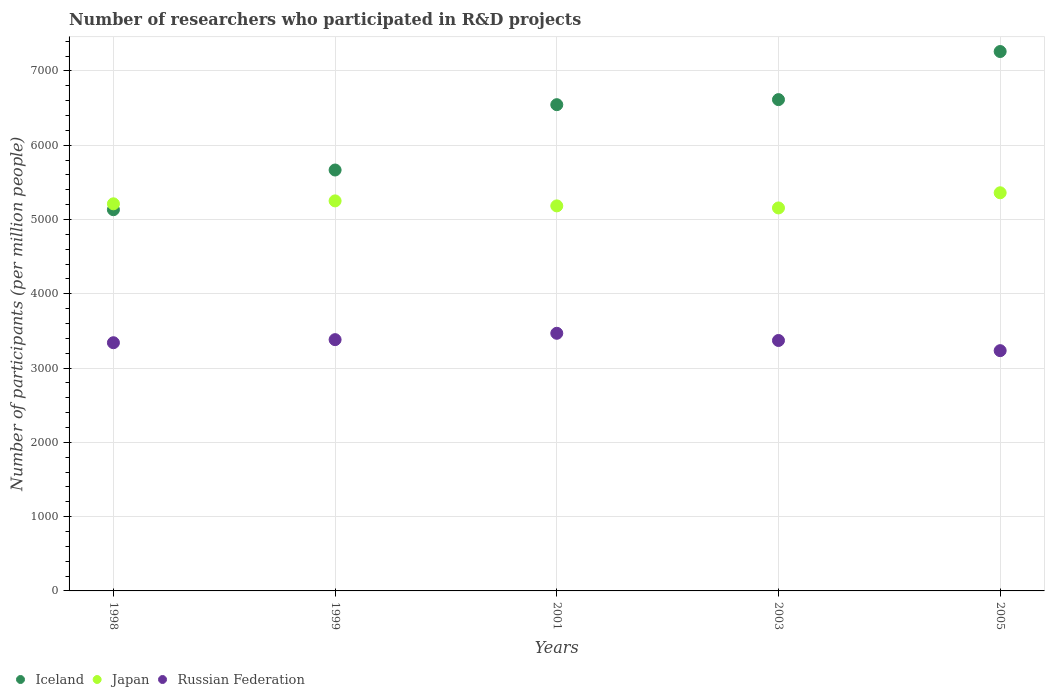Is the number of dotlines equal to the number of legend labels?
Give a very brief answer. Yes. What is the number of researchers who participated in R&D projects in Japan in 2003?
Your answer should be very brief. 5156.09. Across all years, what is the maximum number of researchers who participated in R&D projects in Japan?
Keep it short and to the point. 5360.2. Across all years, what is the minimum number of researchers who participated in R&D projects in Iceland?
Give a very brief answer. 5132.28. What is the total number of researchers who participated in R&D projects in Iceland in the graph?
Provide a succinct answer. 3.12e+04. What is the difference between the number of researchers who participated in R&D projects in Iceland in 1998 and that in 1999?
Your response must be concise. -534.51. What is the difference between the number of researchers who participated in R&D projects in Russian Federation in 1998 and the number of researchers who participated in R&D projects in Iceland in 2005?
Your response must be concise. -3920.25. What is the average number of researchers who participated in R&D projects in Russian Federation per year?
Provide a short and direct response. 3359.86. In the year 1999, what is the difference between the number of researchers who participated in R&D projects in Japan and number of researchers who participated in R&D projects in Russian Federation?
Offer a very short reply. 1868.17. In how many years, is the number of researchers who participated in R&D projects in Russian Federation greater than 7000?
Offer a very short reply. 0. What is the ratio of the number of researchers who participated in R&D projects in Russian Federation in 1999 to that in 2001?
Your answer should be very brief. 0.98. Is the number of researchers who participated in R&D projects in Iceland in 2001 less than that in 2005?
Ensure brevity in your answer.  Yes. What is the difference between the highest and the second highest number of researchers who participated in R&D projects in Japan?
Offer a very short reply. 109.12. What is the difference between the highest and the lowest number of researchers who participated in R&D projects in Iceland?
Provide a short and direct response. 2129.51. In how many years, is the number of researchers who participated in R&D projects in Japan greater than the average number of researchers who participated in R&D projects in Japan taken over all years?
Offer a terse response. 2. Is it the case that in every year, the sum of the number of researchers who participated in R&D projects in Japan and number of researchers who participated in R&D projects in Russian Federation  is greater than the number of researchers who participated in R&D projects in Iceland?
Make the answer very short. Yes. Is the number of researchers who participated in R&D projects in Japan strictly less than the number of researchers who participated in R&D projects in Iceland over the years?
Ensure brevity in your answer.  No. What is the difference between two consecutive major ticks on the Y-axis?
Your response must be concise. 1000. How are the legend labels stacked?
Offer a very short reply. Horizontal. What is the title of the graph?
Offer a terse response. Number of researchers who participated in R&D projects. Does "China" appear as one of the legend labels in the graph?
Offer a very short reply. No. What is the label or title of the X-axis?
Offer a very short reply. Years. What is the label or title of the Y-axis?
Your answer should be compact. Number of participants (per million people). What is the Number of participants (per million people) in Iceland in 1998?
Provide a short and direct response. 5132.28. What is the Number of participants (per million people) of Japan in 1998?
Make the answer very short. 5211.65. What is the Number of participants (per million people) of Russian Federation in 1998?
Offer a terse response. 3341.54. What is the Number of participants (per million people) in Iceland in 1999?
Make the answer very short. 5666.8. What is the Number of participants (per million people) of Japan in 1999?
Give a very brief answer. 5251.07. What is the Number of participants (per million people) of Russian Federation in 1999?
Provide a succinct answer. 3382.9. What is the Number of participants (per million people) of Iceland in 2001?
Offer a very short reply. 6546.33. What is the Number of participants (per million people) in Japan in 2001?
Your answer should be compact. 5183.76. What is the Number of participants (per million people) in Russian Federation in 2001?
Your answer should be compact. 3468.55. What is the Number of participants (per million people) of Iceland in 2003?
Ensure brevity in your answer.  6614.36. What is the Number of participants (per million people) in Japan in 2003?
Provide a succinct answer. 5156.09. What is the Number of participants (per million people) in Russian Federation in 2003?
Offer a very short reply. 3371.6. What is the Number of participants (per million people) in Iceland in 2005?
Give a very brief answer. 7261.79. What is the Number of participants (per million people) in Japan in 2005?
Give a very brief answer. 5360.2. What is the Number of participants (per million people) of Russian Federation in 2005?
Keep it short and to the point. 3234.71. Across all years, what is the maximum Number of participants (per million people) of Iceland?
Offer a terse response. 7261.79. Across all years, what is the maximum Number of participants (per million people) of Japan?
Make the answer very short. 5360.2. Across all years, what is the maximum Number of participants (per million people) of Russian Federation?
Give a very brief answer. 3468.55. Across all years, what is the minimum Number of participants (per million people) of Iceland?
Ensure brevity in your answer.  5132.28. Across all years, what is the minimum Number of participants (per million people) in Japan?
Make the answer very short. 5156.09. Across all years, what is the minimum Number of participants (per million people) of Russian Federation?
Offer a very short reply. 3234.71. What is the total Number of participants (per million people) in Iceland in the graph?
Your answer should be very brief. 3.12e+04. What is the total Number of participants (per million people) of Japan in the graph?
Your answer should be very brief. 2.62e+04. What is the total Number of participants (per million people) of Russian Federation in the graph?
Your response must be concise. 1.68e+04. What is the difference between the Number of participants (per million people) of Iceland in 1998 and that in 1999?
Give a very brief answer. -534.51. What is the difference between the Number of participants (per million people) in Japan in 1998 and that in 1999?
Offer a terse response. -39.42. What is the difference between the Number of participants (per million people) of Russian Federation in 1998 and that in 1999?
Provide a short and direct response. -41.36. What is the difference between the Number of participants (per million people) in Iceland in 1998 and that in 2001?
Offer a terse response. -1414.05. What is the difference between the Number of participants (per million people) of Japan in 1998 and that in 2001?
Make the answer very short. 27.89. What is the difference between the Number of participants (per million people) in Russian Federation in 1998 and that in 2001?
Provide a succinct answer. -127.02. What is the difference between the Number of participants (per million people) in Iceland in 1998 and that in 2003?
Offer a very short reply. -1482.08. What is the difference between the Number of participants (per million people) in Japan in 1998 and that in 2003?
Give a very brief answer. 55.56. What is the difference between the Number of participants (per million people) of Russian Federation in 1998 and that in 2003?
Offer a terse response. -30.07. What is the difference between the Number of participants (per million people) of Iceland in 1998 and that in 2005?
Offer a very short reply. -2129.51. What is the difference between the Number of participants (per million people) of Japan in 1998 and that in 2005?
Make the answer very short. -148.54. What is the difference between the Number of participants (per million people) in Russian Federation in 1998 and that in 2005?
Your answer should be very brief. 106.83. What is the difference between the Number of participants (per million people) in Iceland in 1999 and that in 2001?
Give a very brief answer. -879.53. What is the difference between the Number of participants (per million people) of Japan in 1999 and that in 2001?
Provide a succinct answer. 67.31. What is the difference between the Number of participants (per million people) of Russian Federation in 1999 and that in 2001?
Ensure brevity in your answer.  -85.65. What is the difference between the Number of participants (per million people) in Iceland in 1999 and that in 2003?
Provide a succinct answer. -947.56. What is the difference between the Number of participants (per million people) in Japan in 1999 and that in 2003?
Provide a short and direct response. 94.98. What is the difference between the Number of participants (per million people) in Russian Federation in 1999 and that in 2003?
Offer a terse response. 11.3. What is the difference between the Number of participants (per million people) in Iceland in 1999 and that in 2005?
Your response must be concise. -1594.99. What is the difference between the Number of participants (per million people) of Japan in 1999 and that in 2005?
Give a very brief answer. -109.12. What is the difference between the Number of participants (per million people) of Russian Federation in 1999 and that in 2005?
Your answer should be compact. 148.19. What is the difference between the Number of participants (per million people) in Iceland in 2001 and that in 2003?
Keep it short and to the point. -68.03. What is the difference between the Number of participants (per million people) in Japan in 2001 and that in 2003?
Your response must be concise. 27.67. What is the difference between the Number of participants (per million people) of Russian Federation in 2001 and that in 2003?
Make the answer very short. 96.95. What is the difference between the Number of participants (per million people) of Iceland in 2001 and that in 2005?
Provide a succinct answer. -715.46. What is the difference between the Number of participants (per million people) in Japan in 2001 and that in 2005?
Give a very brief answer. -176.43. What is the difference between the Number of participants (per million people) of Russian Federation in 2001 and that in 2005?
Keep it short and to the point. 233.85. What is the difference between the Number of participants (per million people) of Iceland in 2003 and that in 2005?
Provide a succinct answer. -647.43. What is the difference between the Number of participants (per million people) in Japan in 2003 and that in 2005?
Ensure brevity in your answer.  -204.1. What is the difference between the Number of participants (per million people) of Russian Federation in 2003 and that in 2005?
Offer a very short reply. 136.9. What is the difference between the Number of participants (per million people) of Iceland in 1998 and the Number of participants (per million people) of Japan in 1999?
Your answer should be very brief. -118.79. What is the difference between the Number of participants (per million people) of Iceland in 1998 and the Number of participants (per million people) of Russian Federation in 1999?
Your answer should be compact. 1749.38. What is the difference between the Number of participants (per million people) of Japan in 1998 and the Number of participants (per million people) of Russian Federation in 1999?
Your response must be concise. 1828.75. What is the difference between the Number of participants (per million people) of Iceland in 1998 and the Number of participants (per million people) of Japan in 2001?
Your answer should be compact. -51.48. What is the difference between the Number of participants (per million people) in Iceland in 1998 and the Number of participants (per million people) in Russian Federation in 2001?
Your answer should be very brief. 1663.73. What is the difference between the Number of participants (per million people) of Japan in 1998 and the Number of participants (per million people) of Russian Federation in 2001?
Provide a short and direct response. 1743.1. What is the difference between the Number of participants (per million people) in Iceland in 1998 and the Number of participants (per million people) in Japan in 2003?
Make the answer very short. -23.81. What is the difference between the Number of participants (per million people) of Iceland in 1998 and the Number of participants (per million people) of Russian Federation in 2003?
Provide a succinct answer. 1760.68. What is the difference between the Number of participants (per million people) in Japan in 1998 and the Number of participants (per million people) in Russian Federation in 2003?
Give a very brief answer. 1840.05. What is the difference between the Number of participants (per million people) in Iceland in 1998 and the Number of participants (per million people) in Japan in 2005?
Provide a short and direct response. -227.91. What is the difference between the Number of participants (per million people) of Iceland in 1998 and the Number of participants (per million people) of Russian Federation in 2005?
Give a very brief answer. 1897.58. What is the difference between the Number of participants (per million people) in Japan in 1998 and the Number of participants (per million people) in Russian Federation in 2005?
Your answer should be very brief. 1976.95. What is the difference between the Number of participants (per million people) of Iceland in 1999 and the Number of participants (per million people) of Japan in 2001?
Ensure brevity in your answer.  483.03. What is the difference between the Number of participants (per million people) of Iceland in 1999 and the Number of participants (per million people) of Russian Federation in 2001?
Offer a very short reply. 2198.24. What is the difference between the Number of participants (per million people) of Japan in 1999 and the Number of participants (per million people) of Russian Federation in 2001?
Give a very brief answer. 1782.52. What is the difference between the Number of participants (per million people) in Iceland in 1999 and the Number of participants (per million people) in Japan in 2003?
Offer a terse response. 510.7. What is the difference between the Number of participants (per million people) in Iceland in 1999 and the Number of participants (per million people) in Russian Federation in 2003?
Keep it short and to the point. 2295.19. What is the difference between the Number of participants (per million people) of Japan in 1999 and the Number of participants (per million people) of Russian Federation in 2003?
Offer a very short reply. 1879.47. What is the difference between the Number of participants (per million people) of Iceland in 1999 and the Number of participants (per million people) of Japan in 2005?
Your response must be concise. 306.6. What is the difference between the Number of participants (per million people) of Iceland in 1999 and the Number of participants (per million people) of Russian Federation in 2005?
Ensure brevity in your answer.  2432.09. What is the difference between the Number of participants (per million people) in Japan in 1999 and the Number of participants (per million people) in Russian Federation in 2005?
Offer a very short reply. 2016.36. What is the difference between the Number of participants (per million people) in Iceland in 2001 and the Number of participants (per million people) in Japan in 2003?
Provide a short and direct response. 1390.24. What is the difference between the Number of participants (per million people) in Iceland in 2001 and the Number of participants (per million people) in Russian Federation in 2003?
Make the answer very short. 3174.73. What is the difference between the Number of participants (per million people) of Japan in 2001 and the Number of participants (per million people) of Russian Federation in 2003?
Your response must be concise. 1812.16. What is the difference between the Number of participants (per million people) of Iceland in 2001 and the Number of participants (per million people) of Japan in 2005?
Keep it short and to the point. 1186.13. What is the difference between the Number of participants (per million people) in Iceland in 2001 and the Number of participants (per million people) in Russian Federation in 2005?
Your response must be concise. 3311.62. What is the difference between the Number of participants (per million people) in Japan in 2001 and the Number of participants (per million people) in Russian Federation in 2005?
Ensure brevity in your answer.  1949.06. What is the difference between the Number of participants (per million people) in Iceland in 2003 and the Number of participants (per million people) in Japan in 2005?
Give a very brief answer. 1254.16. What is the difference between the Number of participants (per million people) of Iceland in 2003 and the Number of participants (per million people) of Russian Federation in 2005?
Give a very brief answer. 3379.65. What is the difference between the Number of participants (per million people) in Japan in 2003 and the Number of participants (per million people) in Russian Federation in 2005?
Provide a short and direct response. 1921.39. What is the average Number of participants (per million people) of Iceland per year?
Give a very brief answer. 6244.31. What is the average Number of participants (per million people) of Japan per year?
Offer a very short reply. 5232.56. What is the average Number of participants (per million people) in Russian Federation per year?
Your answer should be very brief. 3359.86. In the year 1998, what is the difference between the Number of participants (per million people) in Iceland and Number of participants (per million people) in Japan?
Give a very brief answer. -79.37. In the year 1998, what is the difference between the Number of participants (per million people) of Iceland and Number of participants (per million people) of Russian Federation?
Provide a short and direct response. 1790.75. In the year 1998, what is the difference between the Number of participants (per million people) in Japan and Number of participants (per million people) in Russian Federation?
Your response must be concise. 1870.12. In the year 1999, what is the difference between the Number of participants (per million people) in Iceland and Number of participants (per million people) in Japan?
Provide a succinct answer. 415.72. In the year 1999, what is the difference between the Number of participants (per million people) of Iceland and Number of participants (per million people) of Russian Federation?
Give a very brief answer. 2283.89. In the year 1999, what is the difference between the Number of participants (per million people) of Japan and Number of participants (per million people) of Russian Federation?
Offer a terse response. 1868.17. In the year 2001, what is the difference between the Number of participants (per million people) of Iceland and Number of participants (per million people) of Japan?
Your response must be concise. 1362.57. In the year 2001, what is the difference between the Number of participants (per million people) of Iceland and Number of participants (per million people) of Russian Federation?
Offer a terse response. 3077.78. In the year 2001, what is the difference between the Number of participants (per million people) of Japan and Number of participants (per million people) of Russian Federation?
Make the answer very short. 1715.21. In the year 2003, what is the difference between the Number of participants (per million people) in Iceland and Number of participants (per million people) in Japan?
Your answer should be compact. 1458.27. In the year 2003, what is the difference between the Number of participants (per million people) in Iceland and Number of participants (per million people) in Russian Federation?
Give a very brief answer. 3242.76. In the year 2003, what is the difference between the Number of participants (per million people) in Japan and Number of participants (per million people) in Russian Federation?
Your answer should be compact. 1784.49. In the year 2005, what is the difference between the Number of participants (per million people) of Iceland and Number of participants (per million people) of Japan?
Provide a succinct answer. 1901.59. In the year 2005, what is the difference between the Number of participants (per million people) in Iceland and Number of participants (per million people) in Russian Federation?
Keep it short and to the point. 4027.08. In the year 2005, what is the difference between the Number of participants (per million people) of Japan and Number of participants (per million people) of Russian Federation?
Make the answer very short. 2125.49. What is the ratio of the Number of participants (per million people) of Iceland in 1998 to that in 1999?
Provide a short and direct response. 0.91. What is the ratio of the Number of participants (per million people) in Russian Federation in 1998 to that in 1999?
Keep it short and to the point. 0.99. What is the ratio of the Number of participants (per million people) of Iceland in 1998 to that in 2001?
Your answer should be very brief. 0.78. What is the ratio of the Number of participants (per million people) of Japan in 1998 to that in 2001?
Your response must be concise. 1.01. What is the ratio of the Number of participants (per million people) in Russian Federation in 1998 to that in 2001?
Keep it short and to the point. 0.96. What is the ratio of the Number of participants (per million people) of Iceland in 1998 to that in 2003?
Keep it short and to the point. 0.78. What is the ratio of the Number of participants (per million people) in Japan in 1998 to that in 2003?
Offer a terse response. 1.01. What is the ratio of the Number of participants (per million people) of Iceland in 1998 to that in 2005?
Your answer should be compact. 0.71. What is the ratio of the Number of participants (per million people) in Japan in 1998 to that in 2005?
Make the answer very short. 0.97. What is the ratio of the Number of participants (per million people) in Russian Federation in 1998 to that in 2005?
Ensure brevity in your answer.  1.03. What is the ratio of the Number of participants (per million people) in Iceland in 1999 to that in 2001?
Your answer should be compact. 0.87. What is the ratio of the Number of participants (per million people) in Russian Federation in 1999 to that in 2001?
Offer a very short reply. 0.98. What is the ratio of the Number of participants (per million people) in Iceland in 1999 to that in 2003?
Make the answer very short. 0.86. What is the ratio of the Number of participants (per million people) in Japan in 1999 to that in 2003?
Keep it short and to the point. 1.02. What is the ratio of the Number of participants (per million people) of Russian Federation in 1999 to that in 2003?
Keep it short and to the point. 1. What is the ratio of the Number of participants (per million people) in Iceland in 1999 to that in 2005?
Your answer should be very brief. 0.78. What is the ratio of the Number of participants (per million people) in Japan in 1999 to that in 2005?
Your answer should be very brief. 0.98. What is the ratio of the Number of participants (per million people) of Russian Federation in 1999 to that in 2005?
Offer a very short reply. 1.05. What is the ratio of the Number of participants (per million people) of Japan in 2001 to that in 2003?
Provide a short and direct response. 1.01. What is the ratio of the Number of participants (per million people) of Russian Federation in 2001 to that in 2003?
Your answer should be very brief. 1.03. What is the ratio of the Number of participants (per million people) of Iceland in 2001 to that in 2005?
Your response must be concise. 0.9. What is the ratio of the Number of participants (per million people) in Japan in 2001 to that in 2005?
Your answer should be very brief. 0.97. What is the ratio of the Number of participants (per million people) in Russian Federation in 2001 to that in 2005?
Your answer should be very brief. 1.07. What is the ratio of the Number of participants (per million people) in Iceland in 2003 to that in 2005?
Provide a short and direct response. 0.91. What is the ratio of the Number of participants (per million people) in Japan in 2003 to that in 2005?
Provide a succinct answer. 0.96. What is the ratio of the Number of participants (per million people) of Russian Federation in 2003 to that in 2005?
Your response must be concise. 1.04. What is the difference between the highest and the second highest Number of participants (per million people) of Iceland?
Make the answer very short. 647.43. What is the difference between the highest and the second highest Number of participants (per million people) of Japan?
Your answer should be compact. 109.12. What is the difference between the highest and the second highest Number of participants (per million people) in Russian Federation?
Your answer should be compact. 85.65. What is the difference between the highest and the lowest Number of participants (per million people) in Iceland?
Your response must be concise. 2129.51. What is the difference between the highest and the lowest Number of participants (per million people) in Japan?
Give a very brief answer. 204.1. What is the difference between the highest and the lowest Number of participants (per million people) in Russian Federation?
Ensure brevity in your answer.  233.85. 